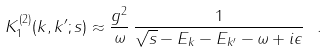<formula> <loc_0><loc_0><loc_500><loc_500>K ^ { ( 2 ) } _ { 1 } ( { k } , { k ^ { \prime } } ; s ) \approx \frac { g ^ { 2 } } { \omega } \, \frac { 1 } { \sqrt { s } - E _ { k } - E _ { k ^ { \prime } } - \omega + i \epsilon } \ .</formula> 